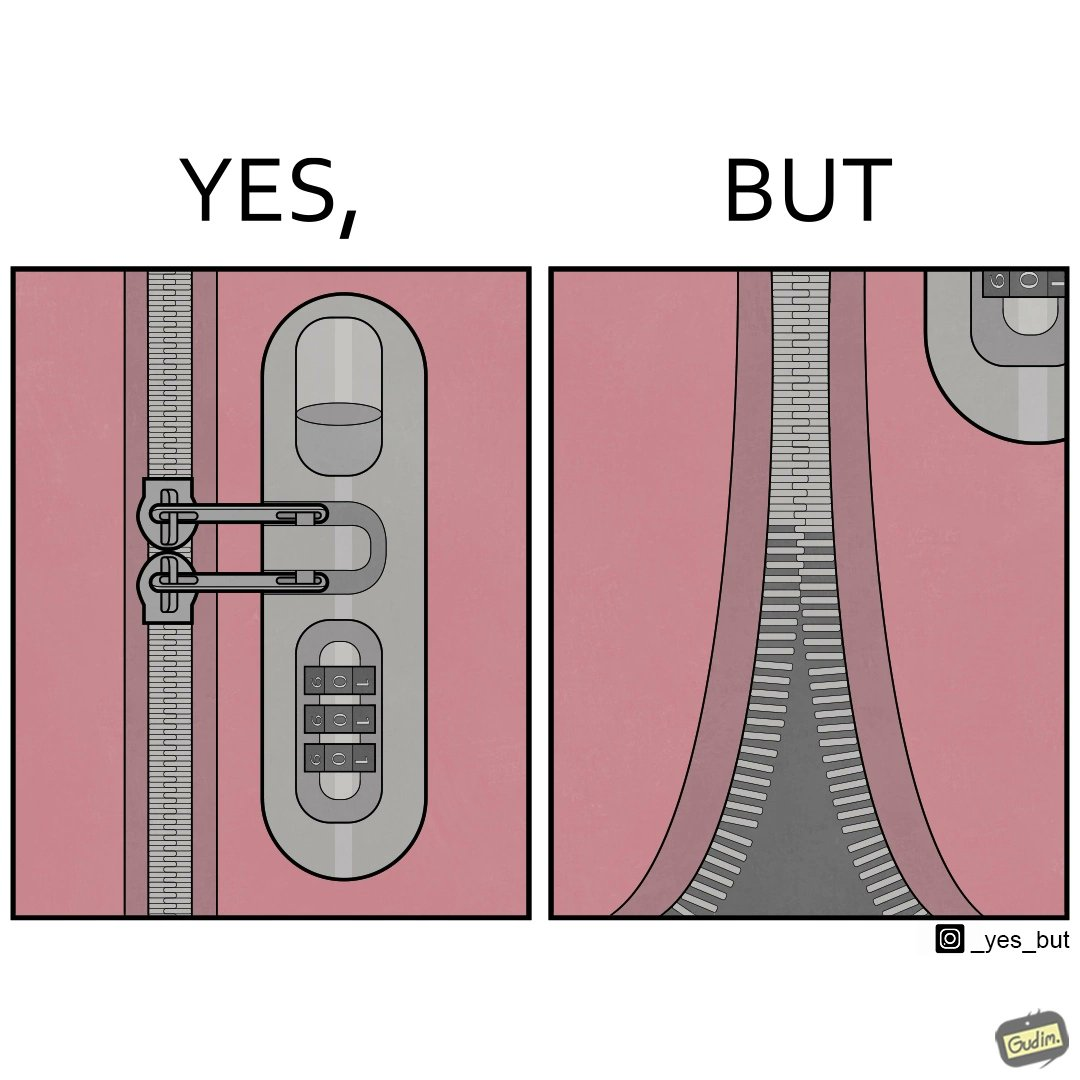Describe the contrast between the left and right parts of this image. In the left part of the image: It is a padlock for chains on a trolley bag In the right part of the image: It is a broken zip chain 